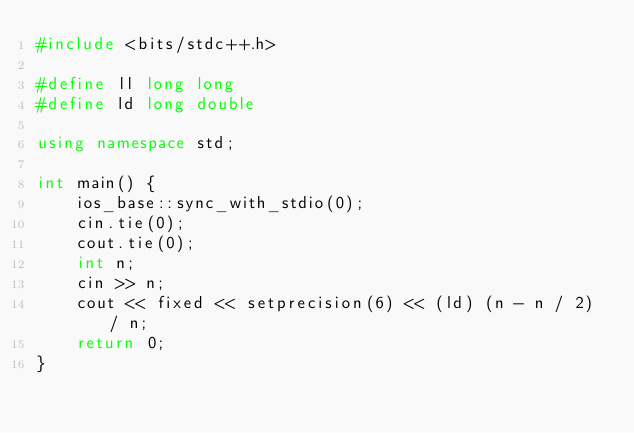Convert code to text. <code><loc_0><loc_0><loc_500><loc_500><_C++_>#include <bits/stdc++.h>

#define ll long long
#define ld long double

using namespace std;

int main() {
    ios_base::sync_with_stdio(0);
    cin.tie(0);
    cout.tie(0);
    int n;
    cin >> n;
    cout << fixed << setprecision(6) << (ld) (n - n / 2) / n;
    return 0;
}</code> 